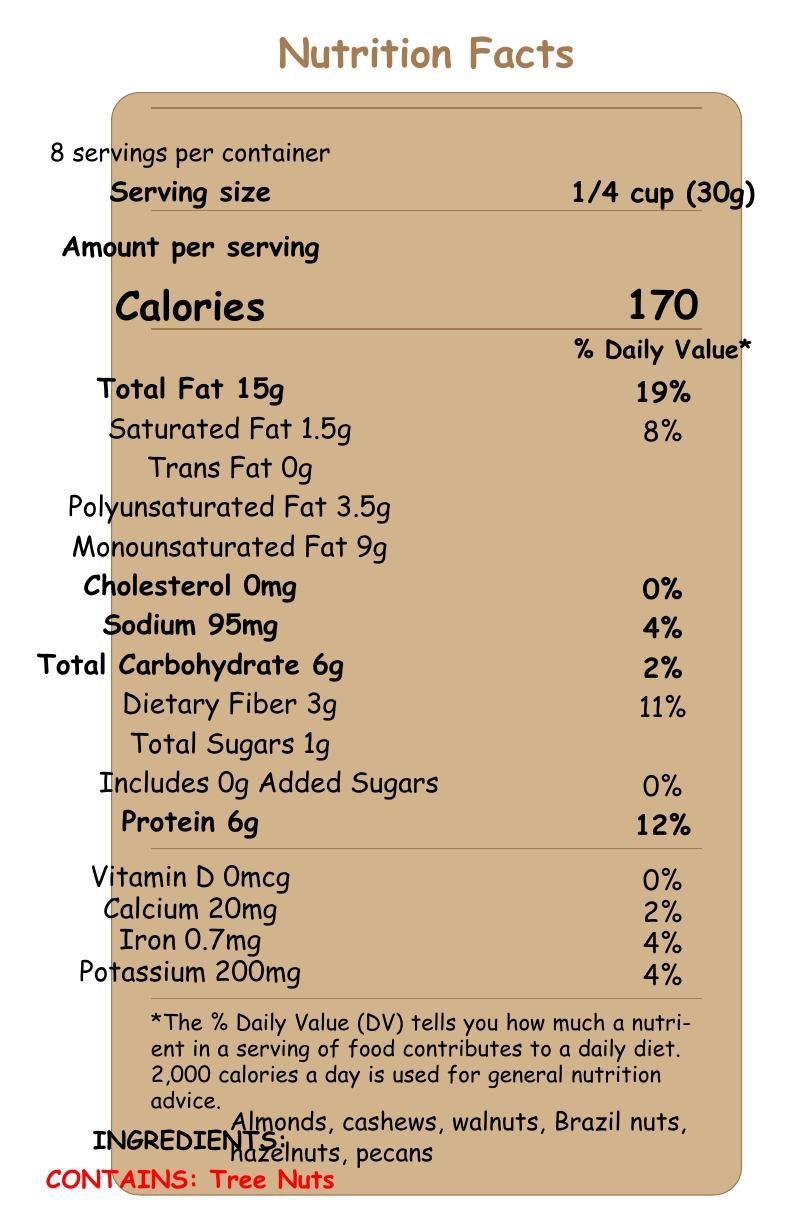What is the serving size of these mixed nuts? The serving size is clearly stated in the document as "1/4 cup (30g)," found under the "Serving size" section.
Answer: 1/4 cup (30g) How many calories are there per serving? The number of calories per serving is specified in the "Calories" section of the document.
Answer: 170 Can you list the types of nuts included in the ingredients? The ingredients are listed near the bottom of the document under the "INGREDIENTS" section.
Answer: Almonds, cashews, walnuts, Brazil nuts, hazelnuts, pecans How much protein is in one serving of mixed nuts? The amount of protein per serving is detailed in the "Protein" section, specifying 6g per serving.
Answer: 6g How many grams of dietary fiber are present in a serving? The "Dietary Fiber" section lists 3g per serving.
Answer: 3g What is the total fat content per serving? The "Total Fat" section indicates that there are 15g of total fat per serving.
Answer: 15g What percentage of the daily value does the total fat content represent? The document details that the 15g of total fat per serving corresponds to 19% of the daily value, as found in the "Total Fat" section.
Answer: 19% How much calcium is provided in one serving? The "Calcium" section shows that one serving contains 20mg of calcium.
Answer: 20mg How much monounsaturated fat is in a serving? The document states in the "Monounsaturated Fat" section that there are 9g of monounsaturated fat per serving.
Answer: 9g What is the sodium content per serving? The sodium content per serving is listed as 95mg in the "Sodium" section.
Answer: 95mg Does this product contain any added sugars? The "Includes 0g Added Sugars" part of the document clearly states that no added sugars are present.
Answer: No What is the percentage of daily value for dietary fiber in a serving? The "Dietary Fiber" section indicates that 3g per serving is 11% of the daily value.
Answer: 11% What is the personal note included at the end of the document? The detailed personal note is not visually represented in the nutrition facts label part of the document.
Answer: Not enough information Which of the following fats is the highest in a serving of mixed nuts?
1. Saturated Fat
2. Polyunsaturated Fat
3. Monounsaturated Fat The "Monounsaturated Fat" section shows it has 9g, higher than both "Saturated Fat" (1.5g) and "Polyunsaturated Fat" (3.5g).
Answer: 3 How many servings are there per container?
A. About 5 servings
B. About 8 servings
C. About 10 servings The "servings per container" section of the document specifies "About 8" servings.
Answer: B Is there any cholesterol present in the serving? The "Cholesterol" section indicates 0mg, which means no cholesterol is present.
Answer: No Summarize the main idea of the document. The document provides comprehensive nutritional info on mixed nuts, highlighting key components like calories, fats, protein, and more, while also listing ingredients and allergens to inform the consumer.
Answer: The document is a Nutrition Facts Label for a serving of mixed nuts, detailing the nutritional information per serving, including calories, fat types, cholesterol, sodium, carbohydrates, dietary fiber, sugars, protein, vitamins, and minerals. It also lists the ingredients and provides an allergen warning. What is the amount of iron in a serving? The "Iron" section in the document shows 0.7mg per serving.
Answer: 0.7mg Are there any tree nuts present in this product? The allergen warning at the bottom of the document states that the product contains tree nuts.
Answer: Yes 